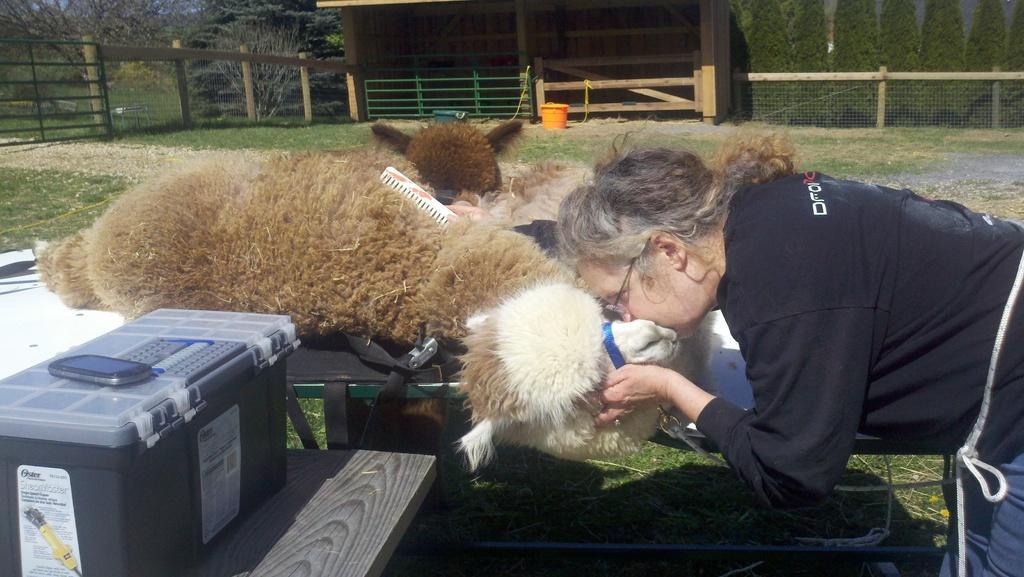Describe this image in one or two sentences. In this image we can see animals on the table and person is holding one of them. In the background we can see shed, mesh, trees, ground and mobile phone on the plastic container. 